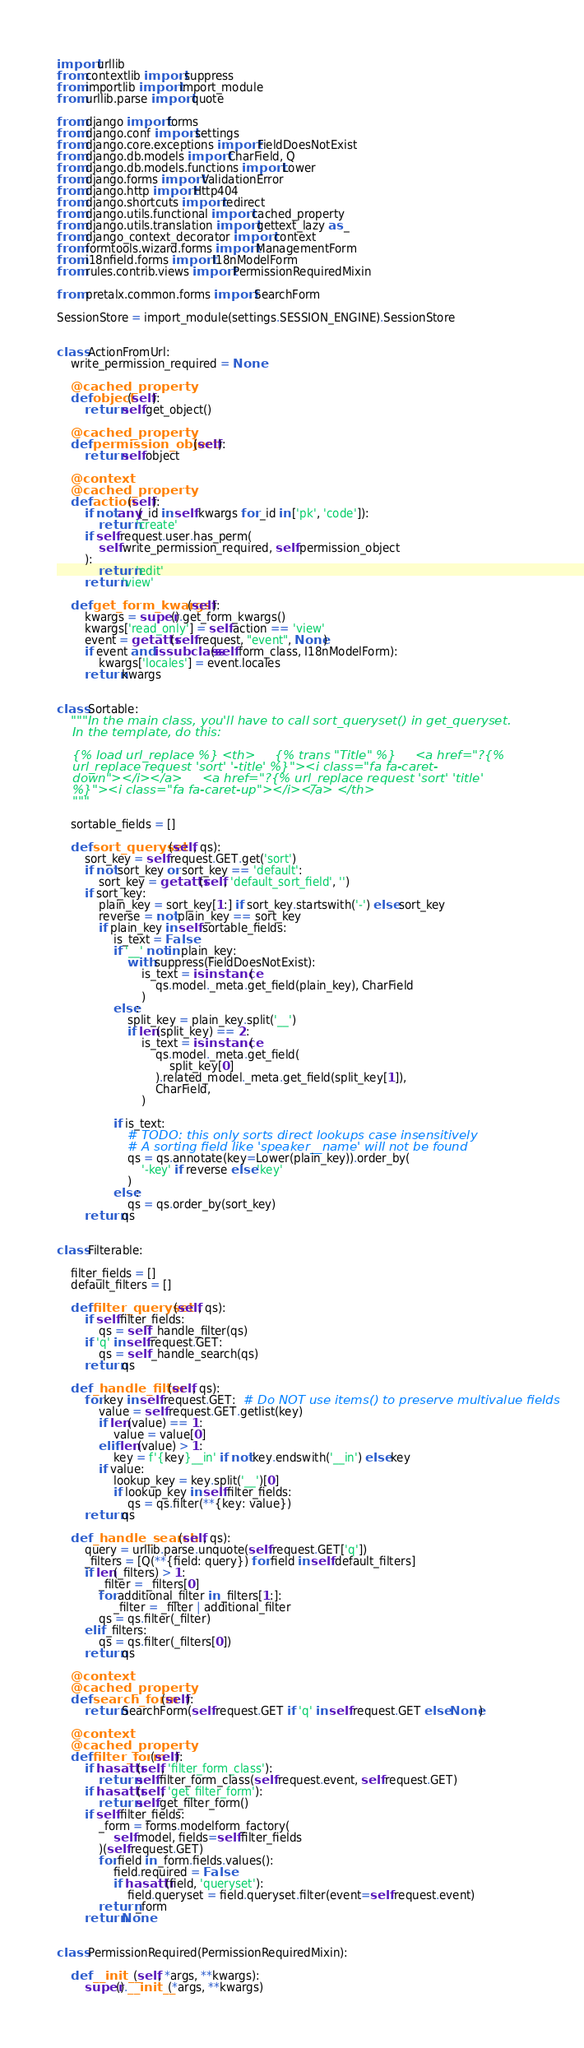<code> <loc_0><loc_0><loc_500><loc_500><_Python_>import urllib
from contextlib import suppress
from importlib import import_module
from urllib.parse import quote

from django import forms
from django.conf import settings
from django.core.exceptions import FieldDoesNotExist
from django.db.models import CharField, Q
from django.db.models.functions import Lower
from django.forms import ValidationError
from django.http import Http404
from django.shortcuts import redirect
from django.utils.functional import cached_property
from django.utils.translation import gettext_lazy as _
from django_context_decorator import context
from formtools.wizard.forms import ManagementForm
from i18nfield.forms import I18nModelForm
from rules.contrib.views import PermissionRequiredMixin

from pretalx.common.forms import SearchForm

SessionStore = import_module(settings.SESSION_ENGINE).SessionStore


class ActionFromUrl:
    write_permission_required = None

    @cached_property
    def object(self):
        return self.get_object()

    @cached_property
    def permission_object(self):
        return self.object

    @context
    @cached_property
    def action(self):
        if not any(_id in self.kwargs for _id in ['pk', 'code']):
            return 'create'
        if self.request.user.has_perm(
            self.write_permission_required, self.permission_object
        ):
            return 'edit'
        return 'view'

    def get_form_kwargs(self):
        kwargs = super().get_form_kwargs()
        kwargs['read_only'] = self.action == 'view'
        event = getattr(self.request, "event", None)
        if event and issubclass(self.form_class, I18nModelForm):
            kwargs['locales'] = event.locales
        return kwargs


class Sortable:
    """In the main class, you'll have to call sort_queryset() in get_queryset.
    In the template, do this:

    {% load url_replace %} <th>     {% trans "Title" %}     <a href="?{%
    url_replace request 'sort' '-title' %}"><i class="fa fa-caret-
    down"></i></a>     <a href="?{% url_replace request 'sort' 'title'
    %}"><i class="fa fa-caret-up"></i></a> </th>
    """

    sortable_fields = []

    def sort_queryset(self, qs):
        sort_key = self.request.GET.get('sort')
        if not sort_key or sort_key == 'default':
            sort_key = getattr(self, 'default_sort_field', '')
        if sort_key:
            plain_key = sort_key[1:] if sort_key.startswith('-') else sort_key
            reverse = not plain_key == sort_key
            if plain_key in self.sortable_fields:
                is_text = False
                if '__' not in plain_key:
                    with suppress(FieldDoesNotExist):
                        is_text = isinstance(
                            qs.model._meta.get_field(plain_key), CharField
                        )
                else:
                    split_key = plain_key.split('__')
                    if len(split_key) == 2:
                        is_text = isinstance(
                            qs.model._meta.get_field(
                                split_key[0]
                            ).related_model._meta.get_field(split_key[1]),
                            CharField,
                        )

                if is_text:
                    # TODO: this only sorts direct lookups case insensitively
                    # A sorting field like 'speaker__name' will not be found
                    qs = qs.annotate(key=Lower(plain_key)).order_by(
                        '-key' if reverse else 'key'
                    )
                else:
                    qs = qs.order_by(sort_key)
        return qs


class Filterable:

    filter_fields = []
    default_filters = []

    def filter_queryset(self, qs):
        if self.filter_fields:
            qs = self._handle_filter(qs)
        if 'q' in self.request.GET:
            qs = self._handle_search(qs)
        return qs

    def _handle_filter(self, qs):
        for key in self.request.GET:  # Do NOT use items() to preserve multivalue fields
            value = self.request.GET.getlist(key)
            if len(value) == 1:
                value = value[0]
            elif len(value) > 1:
                key = f'{key}__in' if not key.endswith('__in') else key
            if value:
                lookup_key = key.split('__')[0]
                if lookup_key in self.filter_fields:
                    qs = qs.filter(**{key: value})
        return qs

    def _handle_search(self, qs):
        query = urllib.parse.unquote(self.request.GET['q'])
        _filters = [Q(**{field: query}) for field in self.default_filters]
        if len(_filters) > 1:
            _filter = _filters[0]
            for additional_filter in _filters[1:]:
                _filter = _filter | additional_filter
            qs = qs.filter(_filter)
        elif _filters:
            qs = qs.filter(_filters[0])
        return qs

    @context
    @cached_property
    def search_form(self):
        return SearchForm(self.request.GET if 'q' in self.request.GET else None)

    @context
    @cached_property
    def filter_form(self):
        if hasattr(self, 'filter_form_class'):
            return self.filter_form_class(self.request.event, self.request.GET)
        if hasattr(self, 'get_filter_form'):
            return self.get_filter_form()
        if self.filter_fields:
            _form = forms.modelform_factory(
                self.model, fields=self.filter_fields
            )(self.request.GET)
            for field in _form.fields.values():
                field.required = False
                if hasattr(field, 'queryset'):
                    field.queryset = field.queryset.filter(event=self.request.event)
            return _form
        return None


class PermissionRequired(PermissionRequiredMixin):

    def __init__(self, *args, **kwargs):
        super().__init__(*args, **kwargs)</code> 